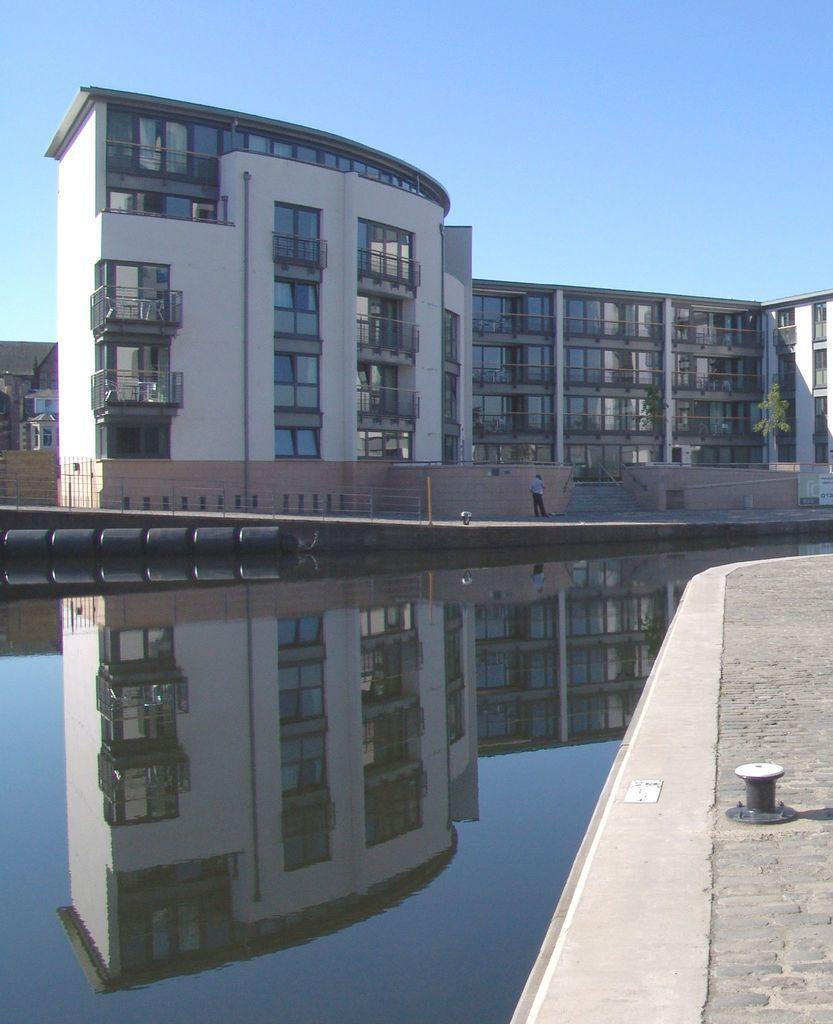Describe this image in one or two sentences. In this picture there is a building and there is a person standing at the staircase and there is a railing and there is a tree. At the top there is sky. At the bottom there is water and there is a reflection of building and sky on the water. 